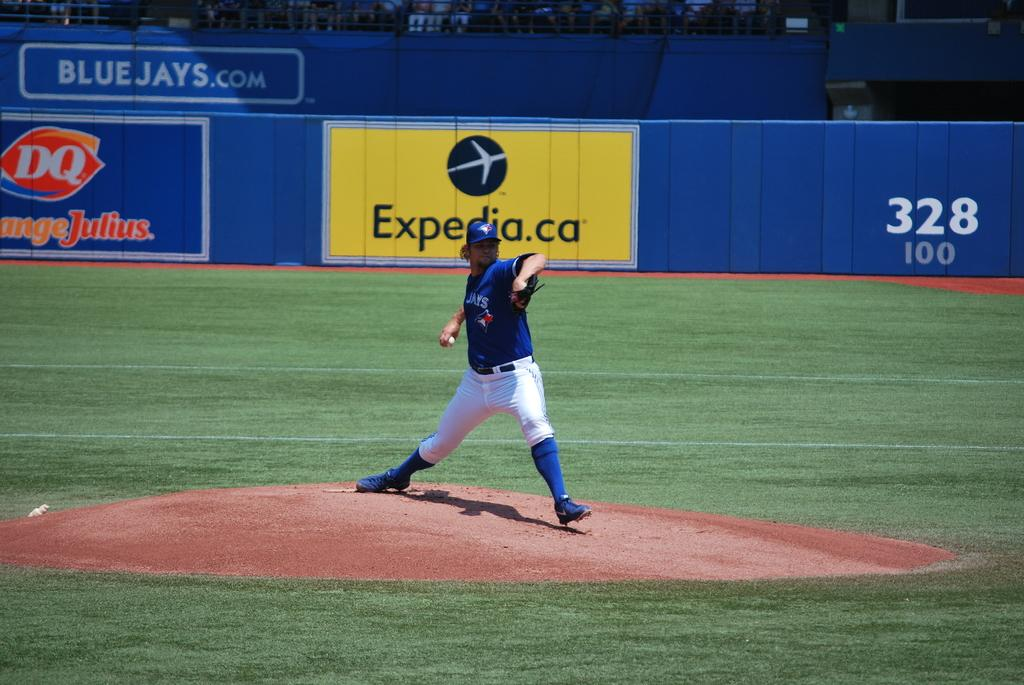<image>
Offer a succinct explanation of the picture presented. A baseball pitcher on the mound about to pitch, in front of stadium wall ads for Expedia.ca and DQ OrangeJulius. 